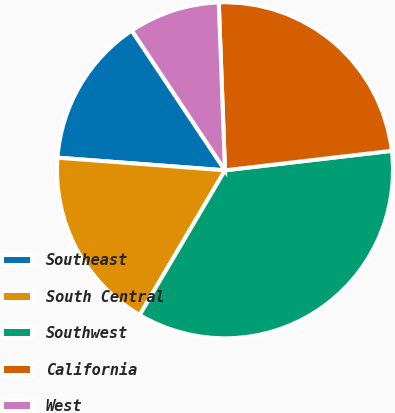<chart> <loc_0><loc_0><loc_500><loc_500><pie_chart><fcel>Southeast<fcel>South Central<fcel>Southwest<fcel>California<fcel>West<nl><fcel>14.44%<fcel>17.72%<fcel>35.33%<fcel>23.74%<fcel>8.77%<nl></chart> 